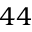Convert formula to latex. <formula><loc_0><loc_0><loc_500><loc_500>4 4</formula> 